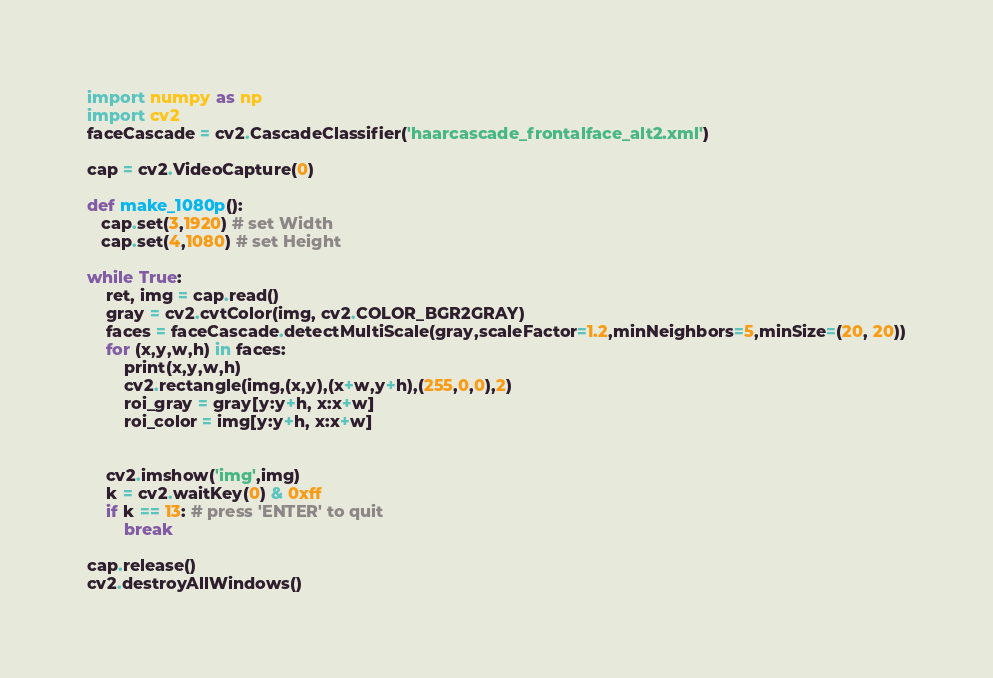Convert code to text. <code><loc_0><loc_0><loc_500><loc_500><_Python_>import numpy as np
import cv2
faceCascade = cv2.CascadeClassifier('haarcascade_frontalface_alt2.xml')

cap = cv2.VideoCapture(0)

def make_1080p():
   cap.set(3,1920) # set Width
   cap.set(4,1080) # set Height   

while True:
    ret, img = cap.read()
    gray = cv2.cvtColor(img, cv2.COLOR_BGR2GRAY)
    faces = faceCascade.detectMultiScale(gray,scaleFactor=1.2,minNeighbors=5,minSize=(20, 20))
    for (x,y,w,h) in faces:    
        print(x,y,w,h)
        cv2.rectangle(img,(x,y),(x+w,y+h),(255,0,0),2)
        roi_gray = gray[y:y+h, x:x+w]
        roi_color = img[y:y+h, x:x+w]
        

    cv2.imshow('img',img)
    k = cv2.waitKey(0) & 0xff
    if k == 13: # press 'ENTER' to quit
        break

cap.release()
cv2.destroyAllWindows()
</code> 